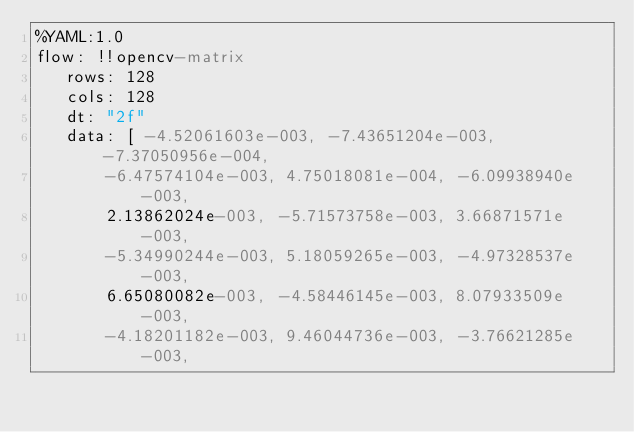<code> <loc_0><loc_0><loc_500><loc_500><_YAML_>%YAML:1.0
flow: !!opencv-matrix
   rows: 128
   cols: 128
   dt: "2f"
   data: [ -4.52061603e-003, -7.43651204e-003, -7.37050956e-004,
       -6.47574104e-003, 4.75018081e-004, -6.09938940e-003,
       2.13862024e-003, -5.71573758e-003, 3.66871571e-003,
       -5.34990244e-003, 5.18059265e-003, -4.97328537e-003,
       6.65080082e-003, -4.58446145e-003, 8.07933509e-003,
       -4.18201182e-003, 9.46044736e-003, -3.76621285e-003,</code> 